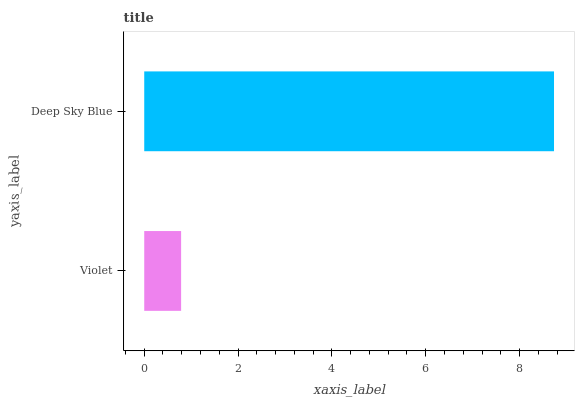Is Violet the minimum?
Answer yes or no. Yes. Is Deep Sky Blue the maximum?
Answer yes or no. Yes. Is Deep Sky Blue the minimum?
Answer yes or no. No. Is Deep Sky Blue greater than Violet?
Answer yes or no. Yes. Is Violet less than Deep Sky Blue?
Answer yes or no. Yes. Is Violet greater than Deep Sky Blue?
Answer yes or no. No. Is Deep Sky Blue less than Violet?
Answer yes or no. No. Is Deep Sky Blue the high median?
Answer yes or no. Yes. Is Violet the low median?
Answer yes or no. Yes. Is Violet the high median?
Answer yes or no. No. Is Deep Sky Blue the low median?
Answer yes or no. No. 